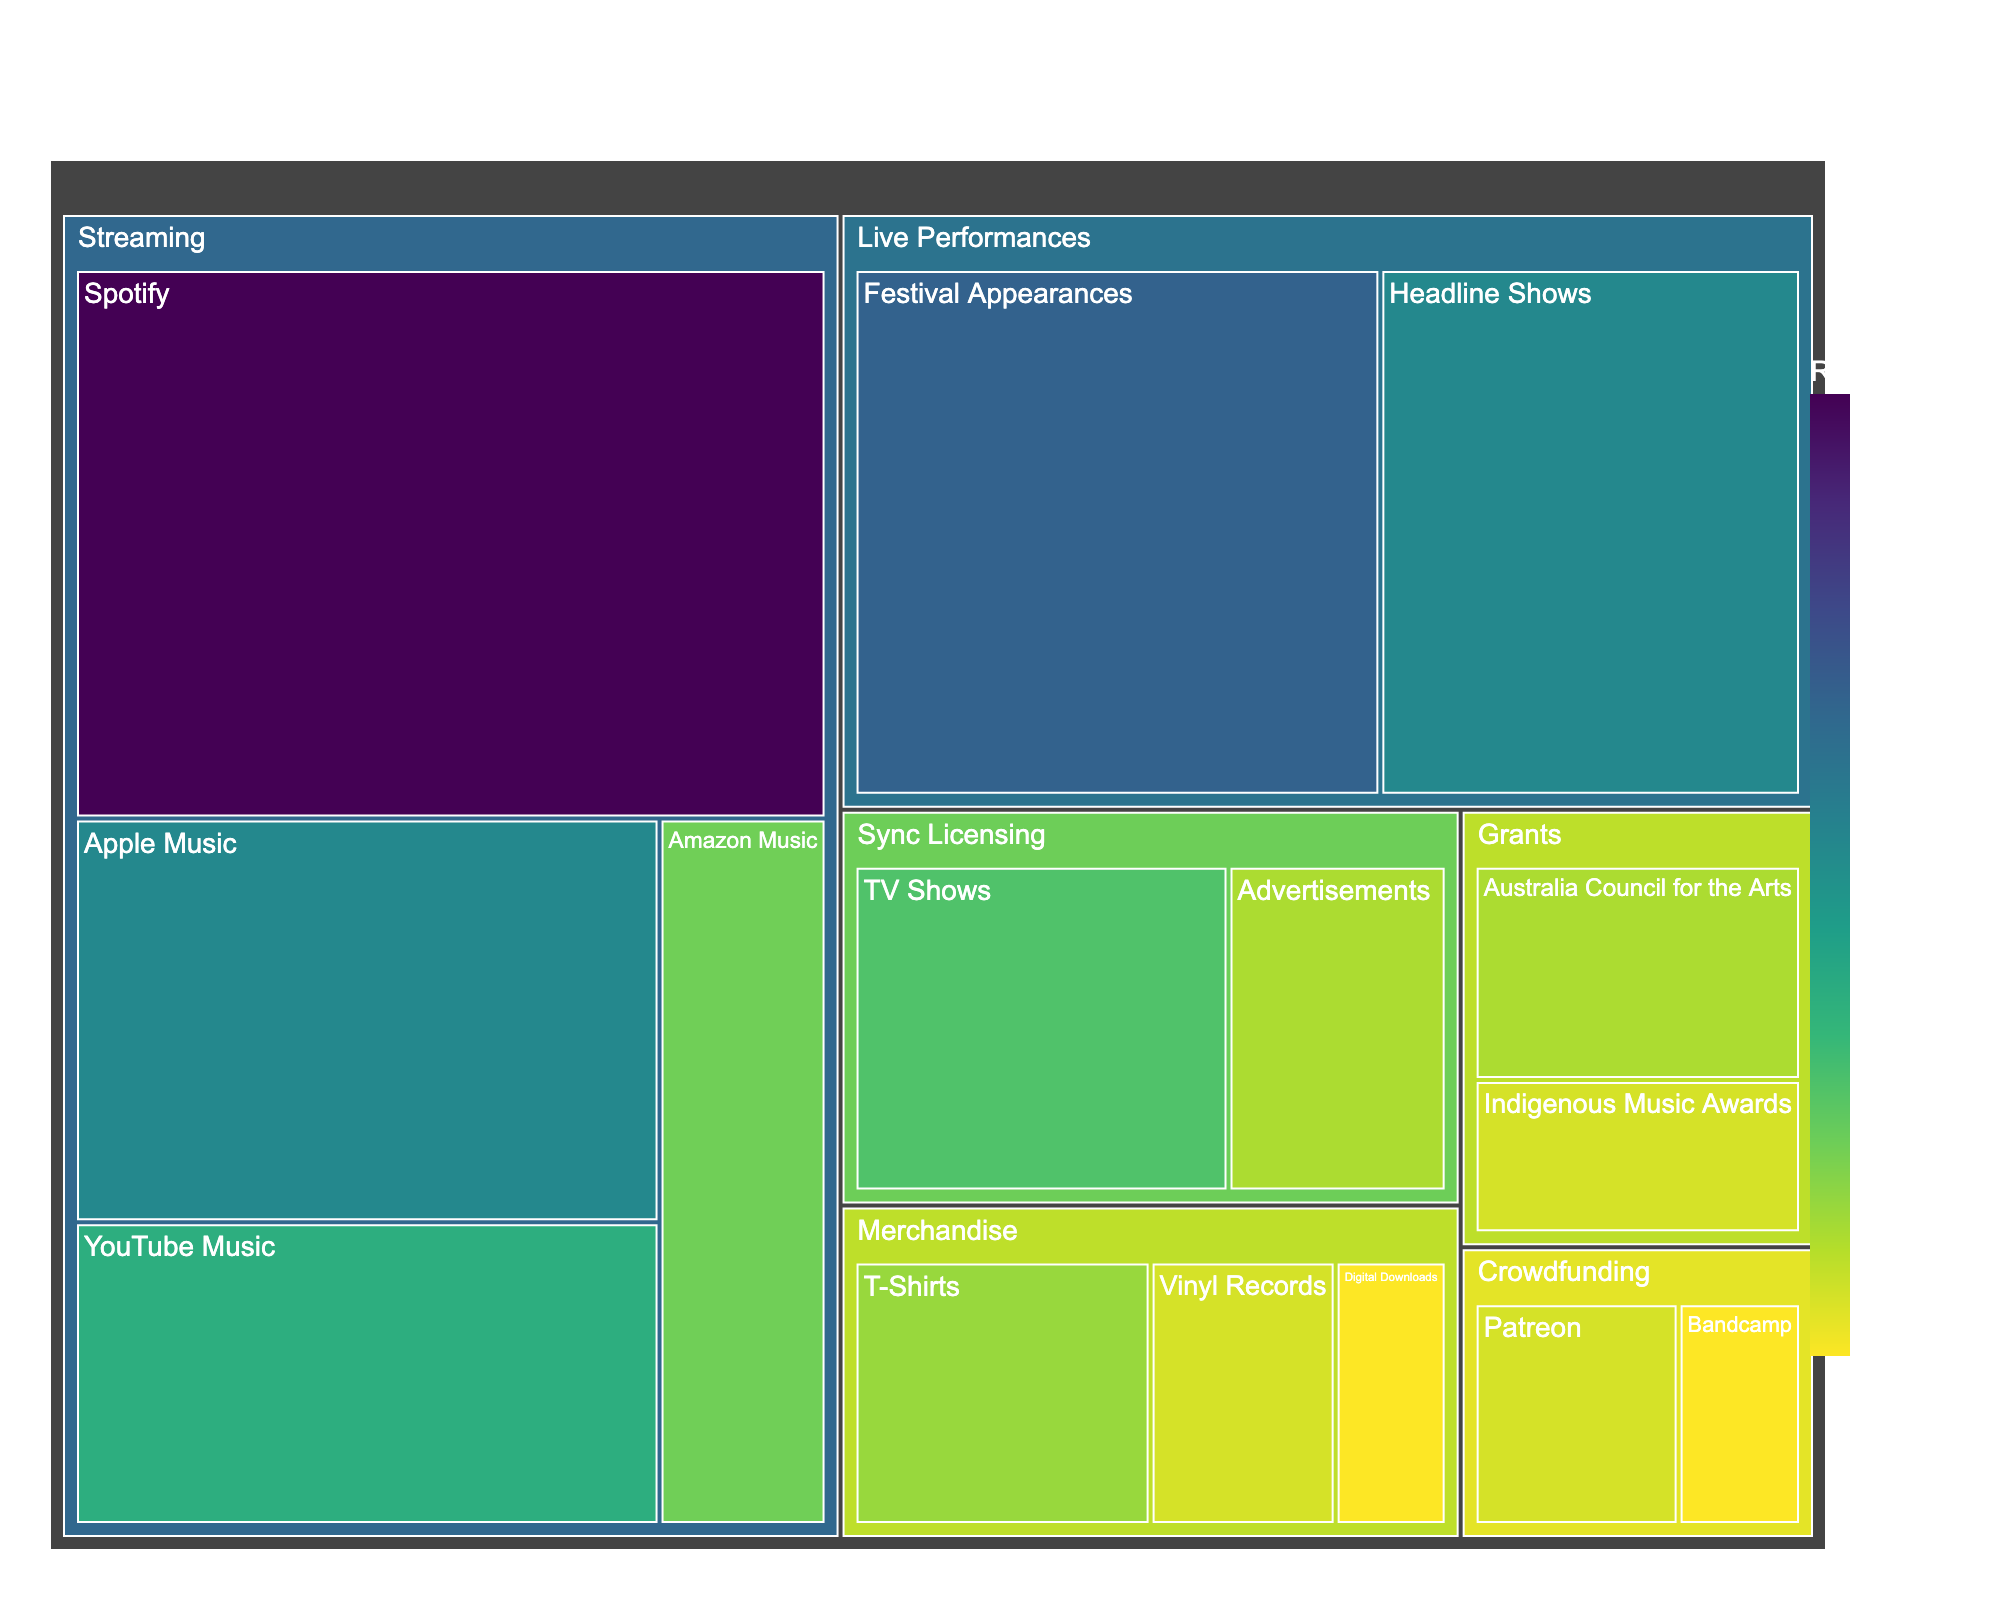What is the title of the figure? Simply look at the top of the figure which contains the title.
Answer: Thelma Plum's Revenue Streams How much revenue comes from Spotify? Check the "Streaming" category and find Spotify's value.
Answer: 35% Which category has the highest revenue share? Observe the entire treemap, and identify the category with the largest area.
Answer: Streaming What is the combined revenue percentage for Live Performances and Merchandise? Add percentages of all subcategories under Live Performances and Merchandise. 25+20+8+5+3 = 61
Answer: 61% Which platform contributes more revenue, Apple Music or YouTube Music? Compare the percentage values of Apple Music and YouTube Music under the Streaming category.
Answer: Apple Music Among "Sync Licensing" subcategories, which one has a lower revenue share? Compare the percentages of the subcategories within Sync Licensing.
Answer: Advertisements What is the total revenue percentage from Crowdfunding sources? Sum the values for Patreon and Bandcamp under Crowdfunding. 5+3 = 8
Answer: 8% Compare the revenue from grants provided by the Australia Council for the Arts and the Indigenous Music Awards. Identify and compare the two values in the Grants category.
Answer: Australia Council for the Arts Which subcategory in the Merchandise category has the smallest revenue share? Examine the subcategories under Merchandise and identify the smallest percentage.
Answer: Digital Downloads How does the revenue from Festival Appearances compare to Headline Shows? Compare the values of Festival Appearances and Headline Shows within Live Performances.
Answer: Festival Appearances have a higher revenue 